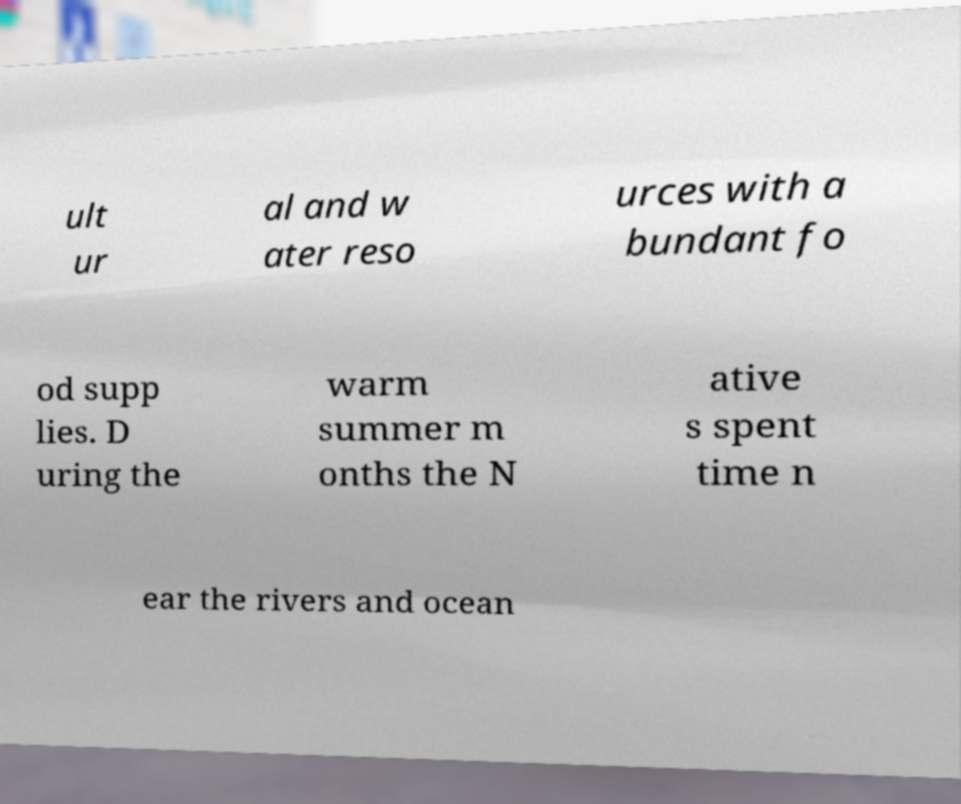Please read and relay the text visible in this image. What does it say? ult ur al and w ater reso urces with a bundant fo od supp lies. D uring the warm summer m onths the N ative s spent time n ear the rivers and ocean 